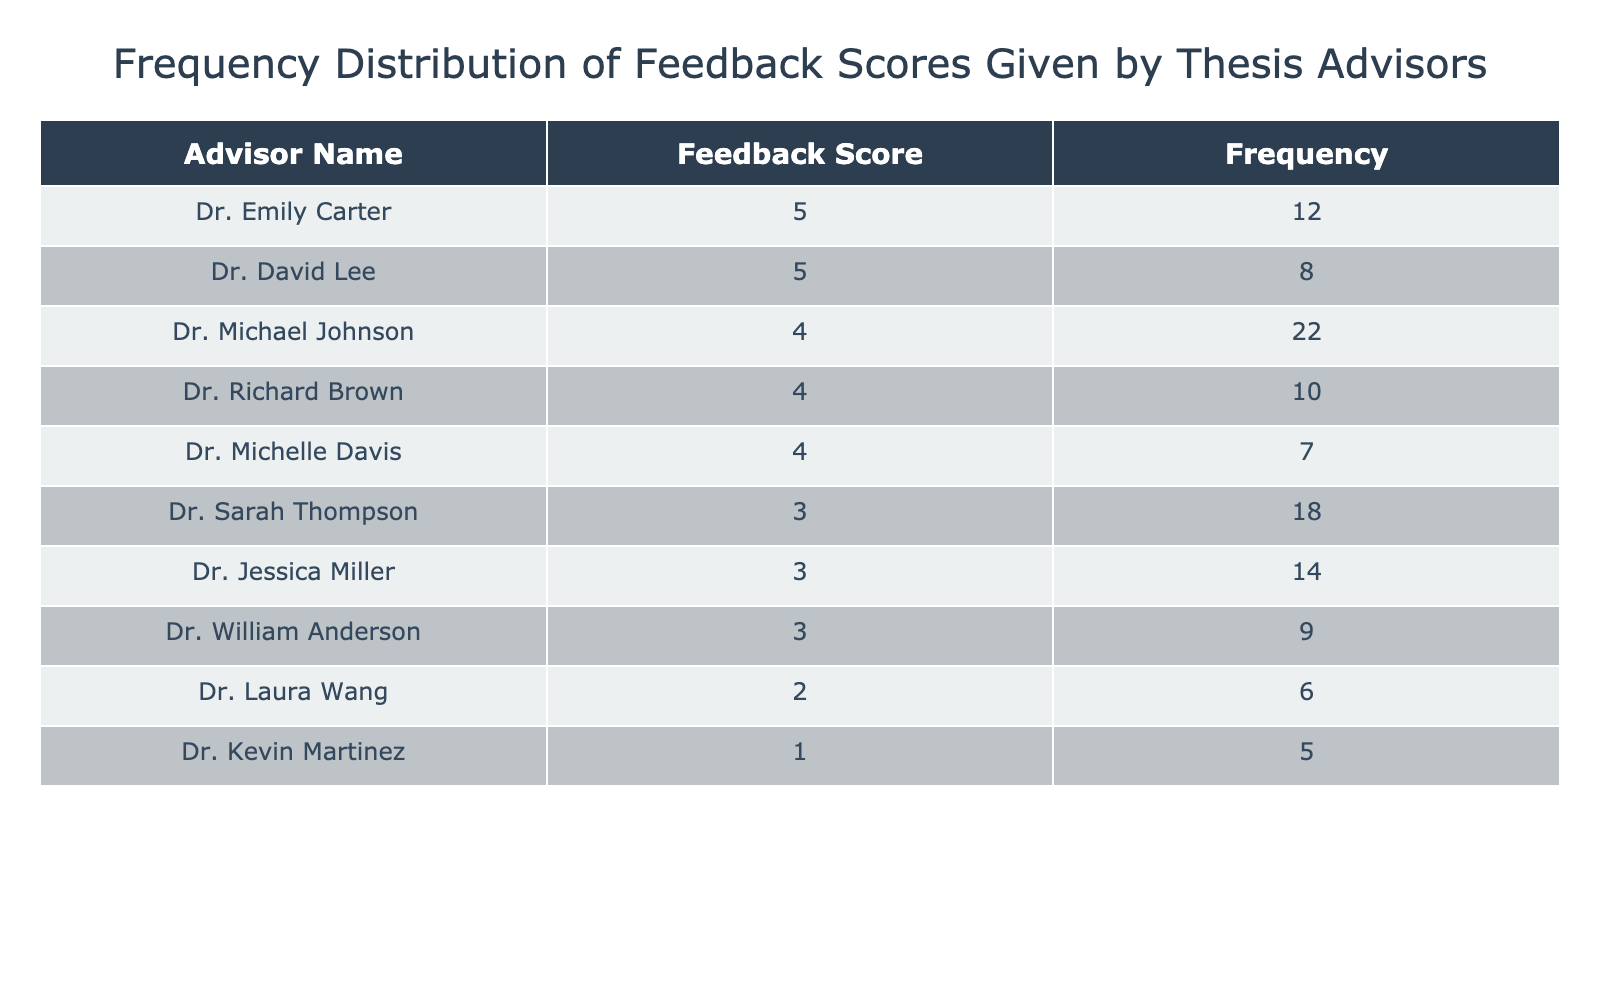What is the Feedback Score given by Dr. Sarah Thompson? The table indicates that Dr. Sarah Thompson has a Feedback Score of 3. This value is specifically listed in the second column corresponding to her name in the first column.
Answer: 3 Which advisor received the highest frequency of scores of 5? According to the table, the highest frequency of Feedback Scores of 5 is received by Dr. Emily Carter (12 times) and Dr. David Lee (8 times).
Answer: Dr. Emily Carter What is the total frequency of Feedback Scores equal to 4? To find the total frequency of Feedback Scores of 4, we add the frequencies from Dr. Michael Johnson (22), Dr. Richard Brown (10), and Dr. Michelle Davis (7). Thus, the total is 22 + 10 + 7 = 39.
Answer: 39 Are there any advisors who received a Feedback Score of 2? By examining the table, Dr. Laura Wang is listed with a Feedback Score of 2, confirming that at least one advisor received this score.
Answer: Yes What is the average Feedback Score of all advisors in the table? To calculate the average, first, we multiply each Feedback Score by its corresponding frequency: (5 * 20 + 4 * 39 + 3 * 41 + 2 * 6 + 1 * 5) = 100 + 156 + 123 + 12 + 5 = 396. We then divide by the total frequency, which is 20 + 39 + 41 + 6 + 5 = 111. Therefore, the average is 396 / 111 ≈ 3.57.
Answer: 3.57 Which advisor received the least amount of feedback? Dr. Kevin Martinez received the least amount of feedback with a frequency of 5, as indicated in the table.
Answer: Dr. Kevin Martinez How many total feedback scores of 3 were given by advisors? To determine the total frequency of Feedback Scores of 3, we need to add Dr. Sarah Thompson (18), Dr. Jessica Miller (14), and Dr. William Anderson (9). Summing these gives us 18 + 14 + 9 = 41.
Answer: 41 Which Feedback Score had the highest combined frequency from advisors? The highest combined frequency belongs to Feedback Score 4, with a total frequency of 39 (22 from Dr. Michael Johnson, 10 from Dr. Richard Brown, and 7 from Dr. Michelle Davis).
Answer: 39 Did all advisors give feedback scores above 1? The data shows that Dr. Kevin Martinez gave a score of 1, which means not all advisors gave scores above 1.
Answer: No 